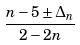<formula> <loc_0><loc_0><loc_500><loc_500>\frac { n - 5 \pm \Delta _ { n } } { 2 - 2 n }</formula> 